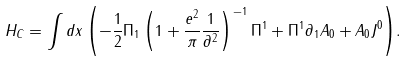Convert formula to latex. <formula><loc_0><loc_0><loc_500><loc_500>H _ { C } = \int { d x \left ( { - \frac { 1 } { 2 } \Pi _ { 1 } \left ( { 1 + \frac { e ^ { 2 } } { \pi } \frac { 1 } { \partial ^ { 2 } } } \right ) ^ { - 1 } \Pi ^ { 1 } + \Pi ^ { 1 } \partial _ { 1 } A _ { 0 } + A _ { 0 } J ^ { 0 } } \right ) } .</formula> 